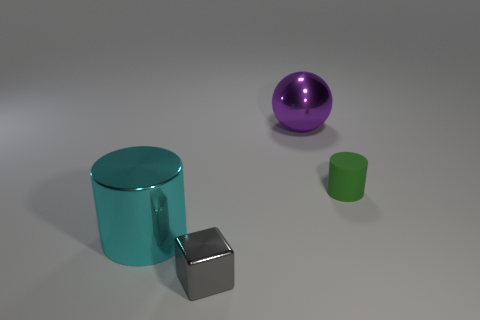Add 3 large green cylinders. How many objects exist? 7 Subtract all balls. How many objects are left? 3 Add 2 metallic spheres. How many metallic spheres are left? 3 Add 4 tiny shiny objects. How many tiny shiny objects exist? 5 Subtract 1 gray cubes. How many objects are left? 3 Subtract all cyan metallic cylinders. Subtract all tiny green rubber objects. How many objects are left? 2 